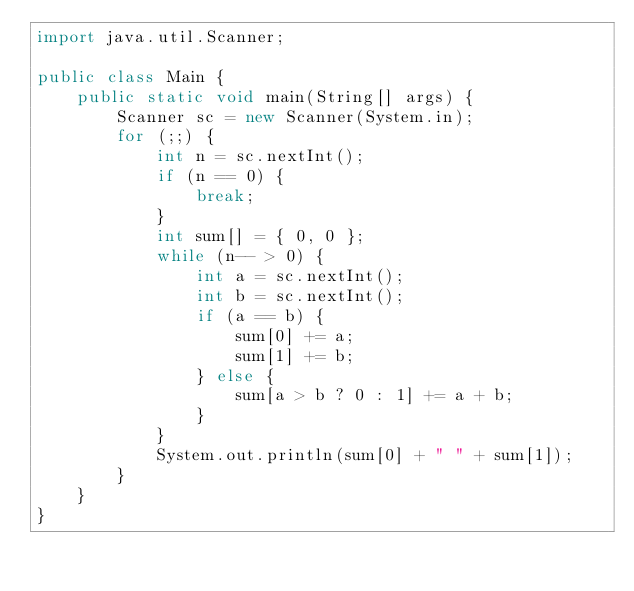<code> <loc_0><loc_0><loc_500><loc_500><_Java_>import java.util.Scanner;

public class Main {
    public static void main(String[] args) {
        Scanner sc = new Scanner(System.in);
        for (;;) {
            int n = sc.nextInt();
            if (n == 0) {
                break;
            }
            int sum[] = { 0, 0 };
            while (n-- > 0) {
                int a = sc.nextInt();
                int b = sc.nextInt();
                if (a == b) {
                    sum[0] += a;
                    sum[1] += b;
                } else {
                    sum[a > b ? 0 : 1] += a + b;
                }
            }
            System.out.println(sum[0] + " " + sum[1]);
        }
    }
}

</code> 